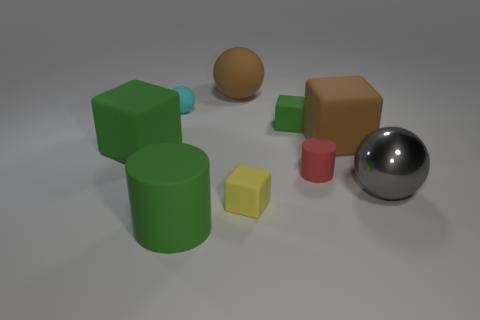Add 1 shiny things. How many objects exist? 10 Subtract all cubes. How many objects are left? 5 Add 2 big purple metal spheres. How many big purple metal spheres exist? 2 Subtract 1 green cylinders. How many objects are left? 8 Subtract all small yellow blocks. Subtract all small red metal spheres. How many objects are left? 8 Add 8 shiny things. How many shiny things are left? 9 